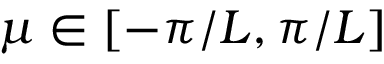Convert formula to latex. <formula><loc_0><loc_0><loc_500><loc_500>\mu \in [ - \pi / L , \pi / L ]</formula> 